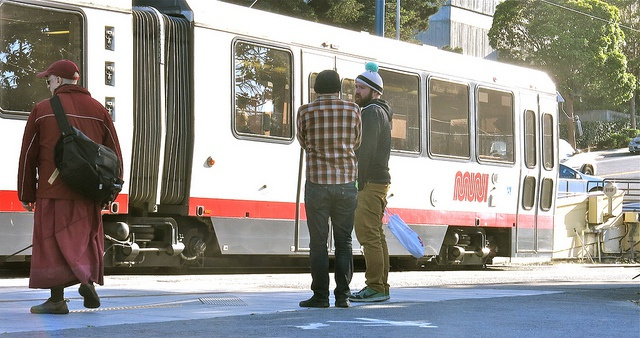Describe the objects in this image and their specific colors. I can see train in darkgray, white, gray, and black tones, bus in darkgray, white, gray, and black tones, people in darkgray, maroon, black, and brown tones, people in darkgray, black, and gray tones, and people in darkgray, darkgreen, gray, and black tones in this image. 